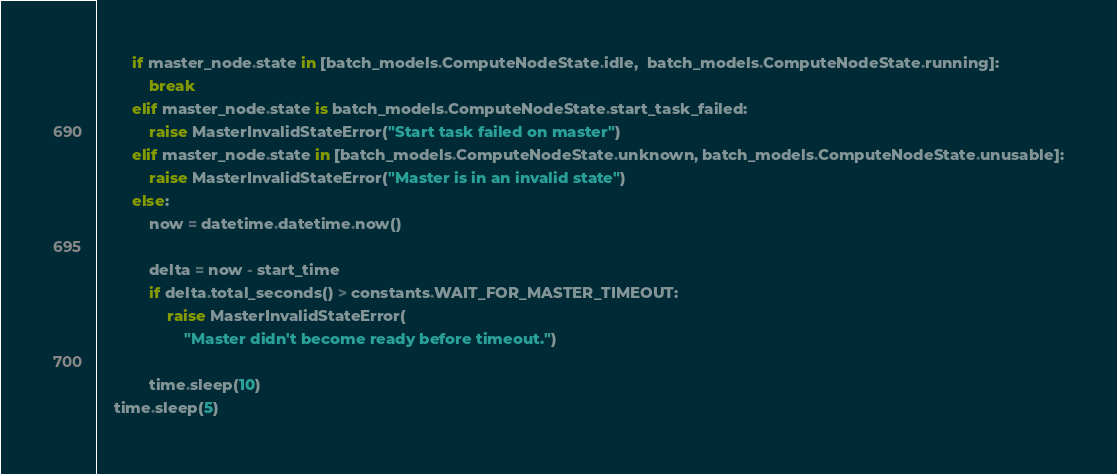<code> <loc_0><loc_0><loc_500><loc_500><_Python_>
        if master_node.state in [batch_models.ComputeNodeState.idle,  batch_models.ComputeNodeState.running]:
            break
        elif master_node.state is batch_models.ComputeNodeState.start_task_failed:
            raise MasterInvalidStateError("Start task failed on master")
        elif master_node.state in [batch_models.ComputeNodeState.unknown, batch_models.ComputeNodeState.unusable]:
            raise MasterInvalidStateError("Master is in an invalid state")
        else:
            now = datetime.datetime.now()

            delta = now - start_time
            if delta.total_seconds() > constants.WAIT_FOR_MASTER_TIMEOUT:
                raise MasterInvalidStateError(
                    "Master didn't become ready before timeout.")

            time.sleep(10)
    time.sleep(5)
</code> 